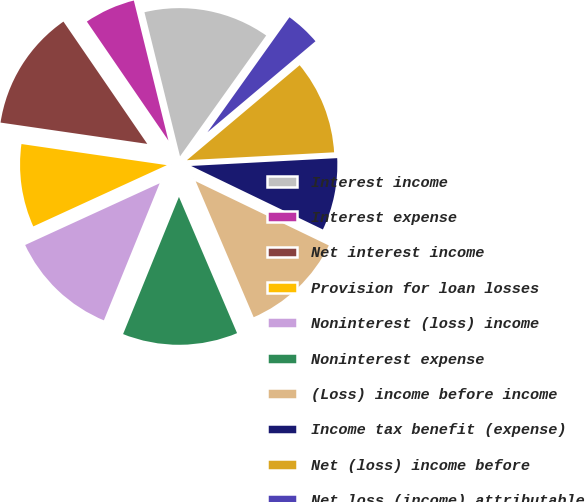Convert chart. <chart><loc_0><loc_0><loc_500><loc_500><pie_chart><fcel>Interest income<fcel>Interest expense<fcel>Net interest income<fcel>Provision for loan losses<fcel>Noninterest (loss) income<fcel>Noninterest expense<fcel>(Loss) income before income<fcel>Income tax benefit (expense)<fcel>Net (loss) income before<fcel>Net loss (income) attributable<nl><fcel>13.71%<fcel>5.71%<fcel>13.14%<fcel>9.14%<fcel>12.0%<fcel>12.57%<fcel>11.43%<fcel>8.0%<fcel>10.29%<fcel>4.0%<nl></chart> 